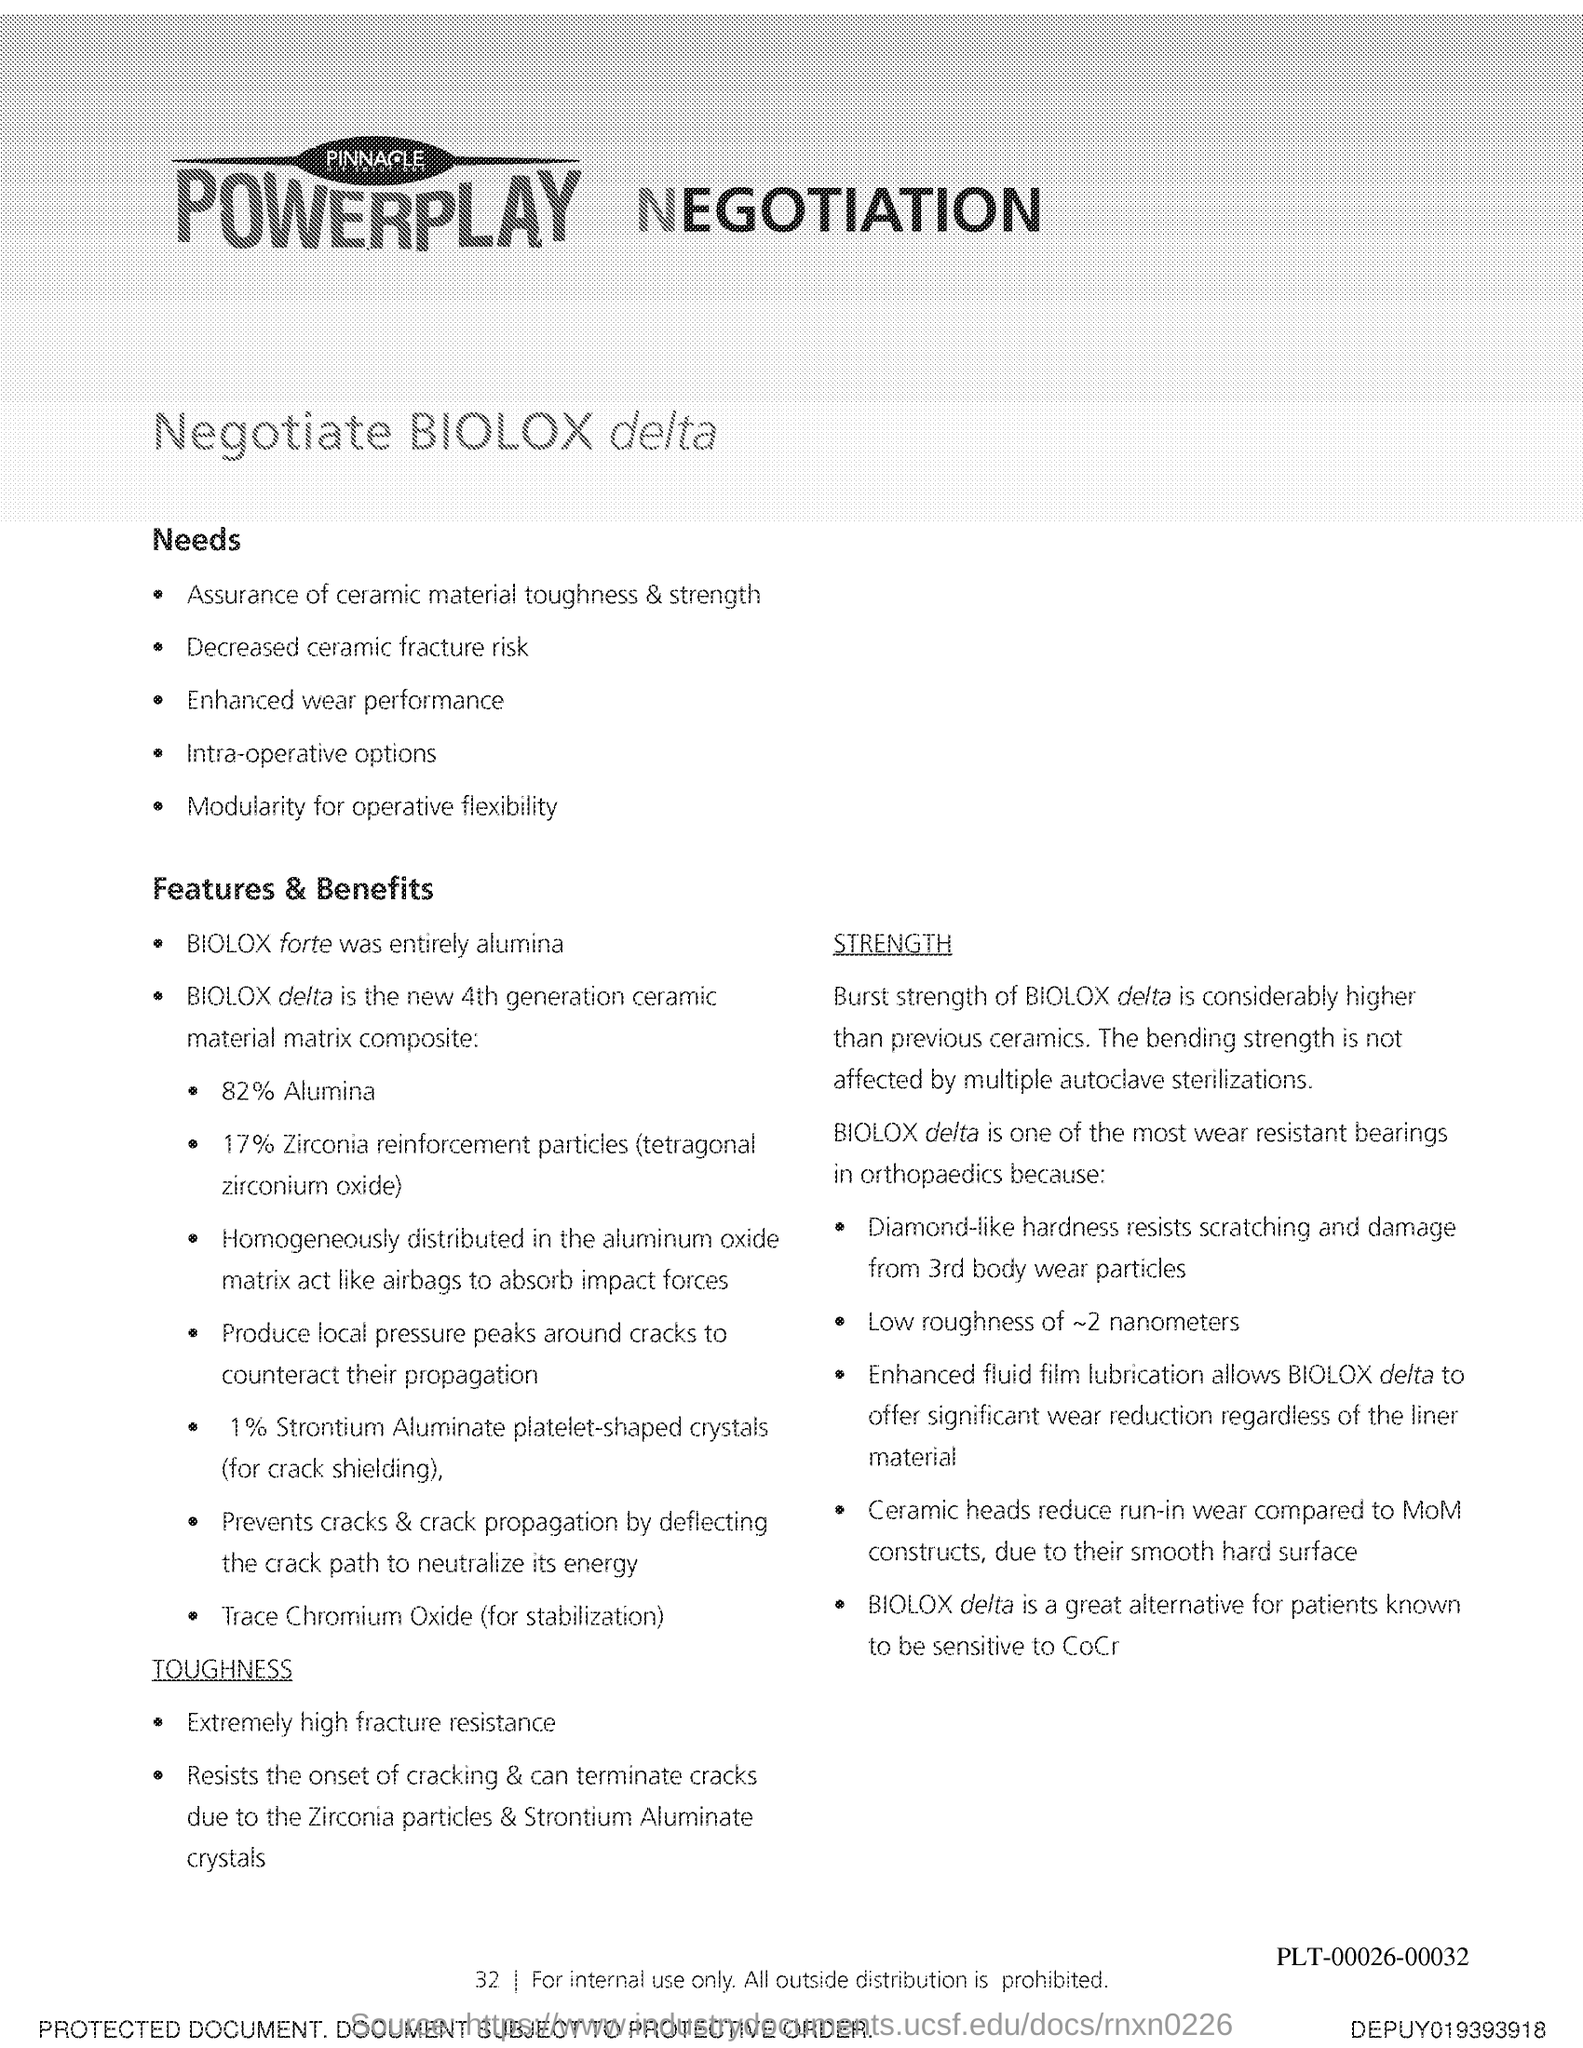List a handful of essential elements in this visual. The page number is 32, as declared. 